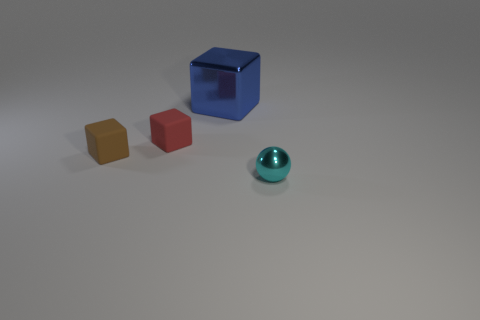How many other things are there of the same material as the tiny red object?
Your response must be concise. 1. What is the shape of the large blue object that is the same material as the tiny cyan thing?
Provide a succinct answer. Cube. Are there any other things that have the same color as the large block?
Your answer should be very brief. No. Are there more blue metallic cubes on the right side of the metal ball than purple shiny cubes?
Your answer should be compact. No. Does the large object have the same shape as the metallic object that is right of the large metal object?
Provide a short and direct response. No. How many blue metal things have the same size as the red object?
Offer a terse response. 0. There is a tiny object that is on the right side of the blue shiny cube behind the tiny red rubber cube; how many rubber objects are on the right side of it?
Give a very brief answer. 0. Are there the same number of matte blocks that are right of the small brown block and tiny brown matte blocks that are in front of the small metallic thing?
Your answer should be very brief. No. What number of other cyan metallic things are the same shape as the large metallic object?
Offer a terse response. 0. Are there any objects that have the same material as the small ball?
Your response must be concise. Yes. 